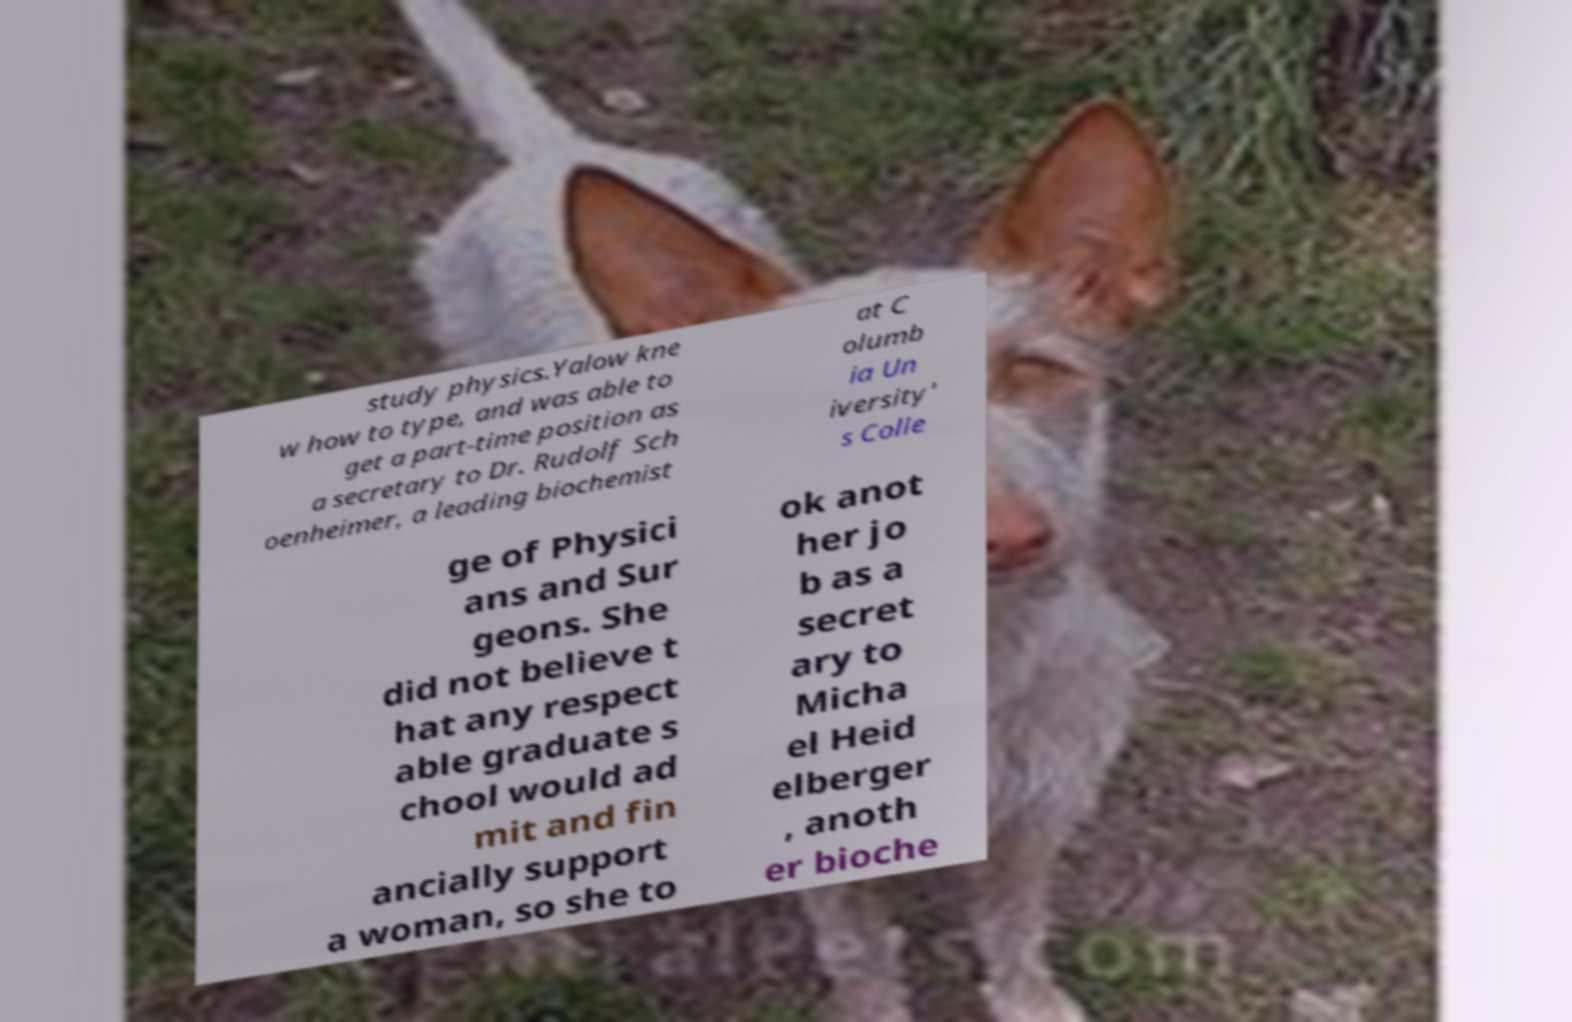Please identify and transcribe the text found in this image. study physics.Yalow kne w how to type, and was able to get a part-time position as a secretary to Dr. Rudolf Sch oenheimer, a leading biochemist at C olumb ia Un iversity' s Colle ge of Physici ans and Sur geons. She did not believe t hat any respect able graduate s chool would ad mit and fin ancially support a woman, so she to ok anot her jo b as a secret ary to Micha el Heid elberger , anoth er bioche 